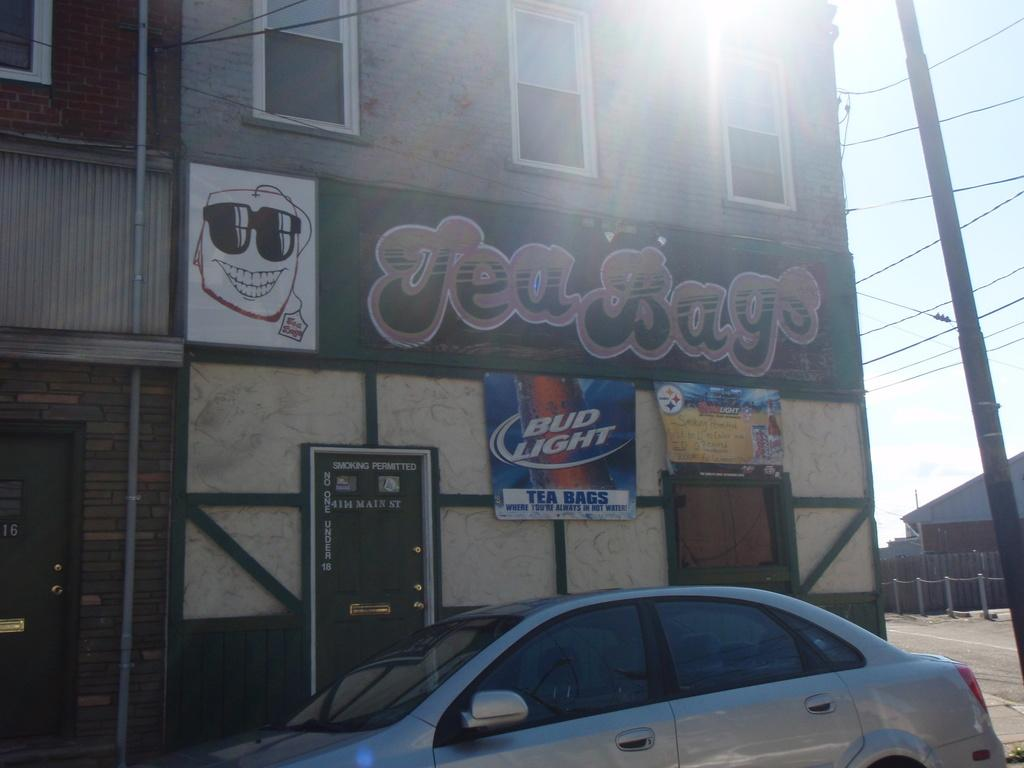What is on the ground in the image? There is a car on the ground in the image. What type of structures can be seen in the image? There are buildings with windows in the image. What decorative elements are present in the image? Banners are present in the image. What type of infrastructure can be seen in the image? Wires and a pole are visible in the image. What is visible in the background of the image? The sky is visible in the background of the image. Can you see a squirrel climbing the pole in the image? There is no squirrel present in the image; it only features a car, buildings, banners, wires, a pole, and the sky. How many men are visible in the image? There is no mention of men in the provided facts, so we cannot determine their presence in the image. 